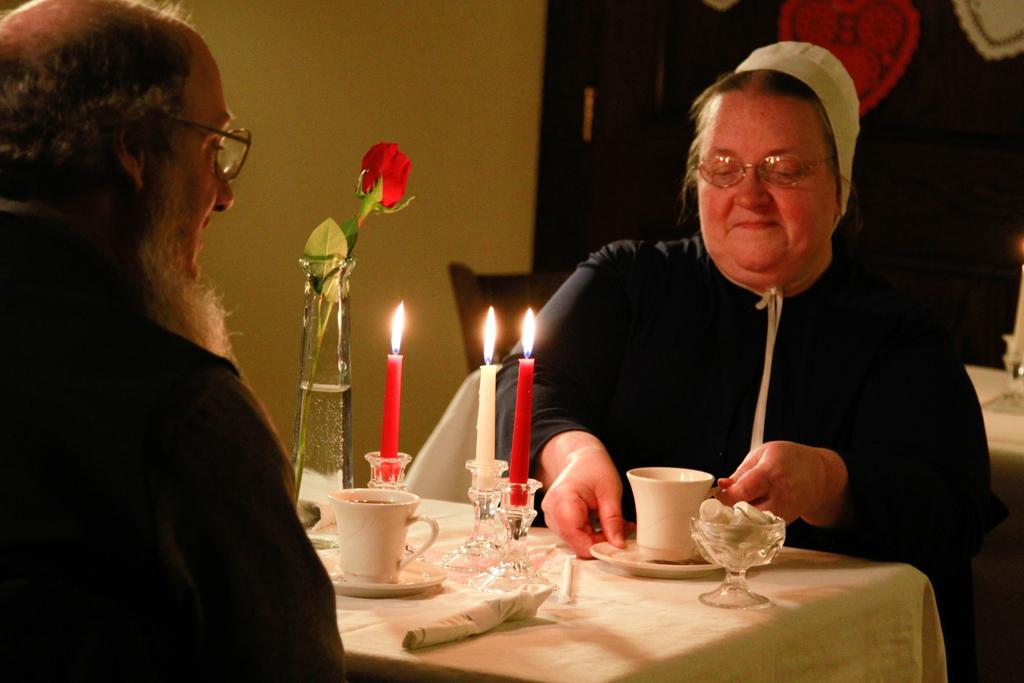How many people are in the image? There are two persons in the image. What are the persons doing in the image? The persons are seated on chairs. What objects can be seen on the table in the image? There is a cup, candles, and a flower on the table. What type of pipe is the grandmother smoking in the image? There is no grandmother or pipe present in the image. Can you describe the tiger's behavior in the image? There is no tiger present in the image. 